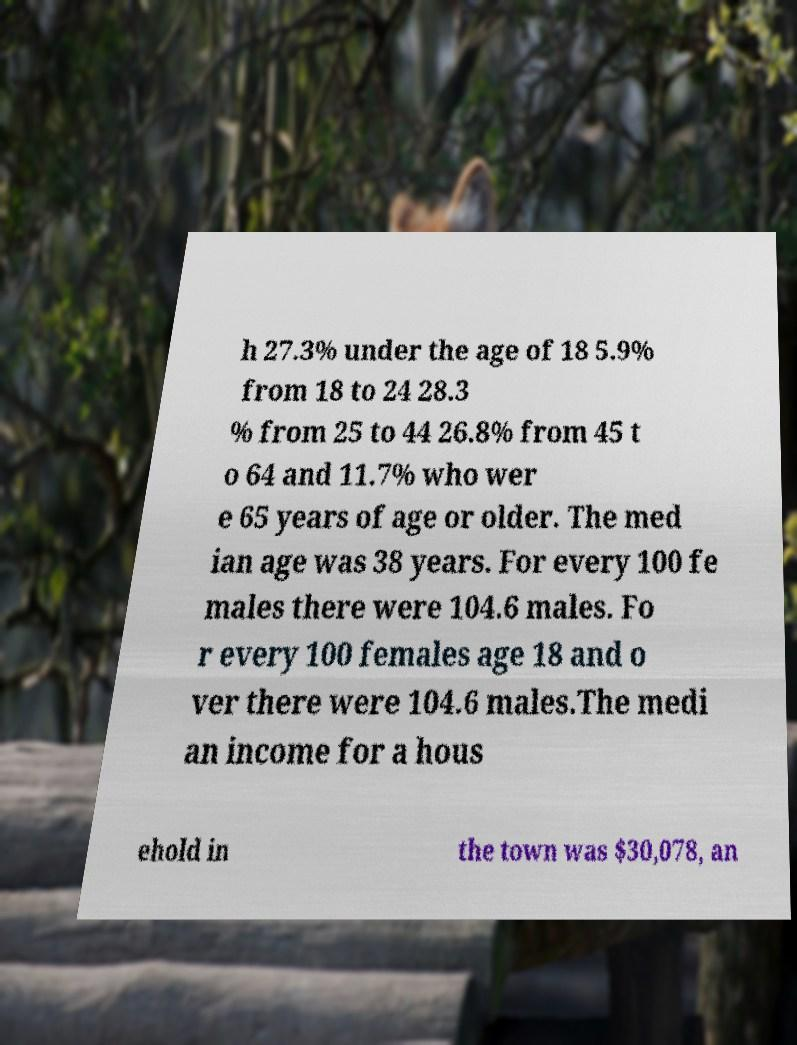Please read and relay the text visible in this image. What does it say? h 27.3% under the age of 18 5.9% from 18 to 24 28.3 % from 25 to 44 26.8% from 45 t o 64 and 11.7% who wer e 65 years of age or older. The med ian age was 38 years. For every 100 fe males there were 104.6 males. Fo r every 100 females age 18 and o ver there were 104.6 males.The medi an income for a hous ehold in the town was $30,078, an 